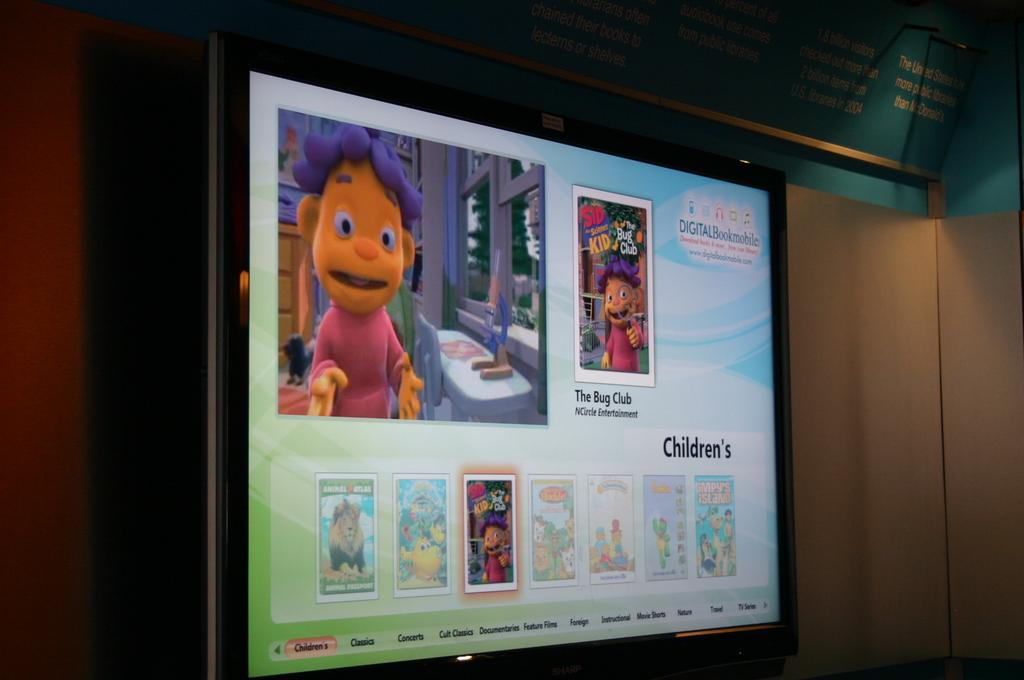What is the main object in the middle of the image? There is a screen in the middle of the image. What type of content is displayed on the screen? The screen has cartoon images and texts. What can be seen in the background of the image? There is a wall in the background of the image. What type of trousers are the characters wearing in the cartoon images on the screen? There is no information about the characters' clothing in the image, as it only shows the screen with cartoon images and texts. What event or meeting is taking place in the image? There is no event or meeting depicted in the image; it only features a screen with cartoon images and texts. 